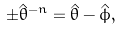<formula> <loc_0><loc_0><loc_500><loc_500>\pm \hat { \theta } ^ { - n } = \hat { \theta } - \hat { \phi } ,</formula> 